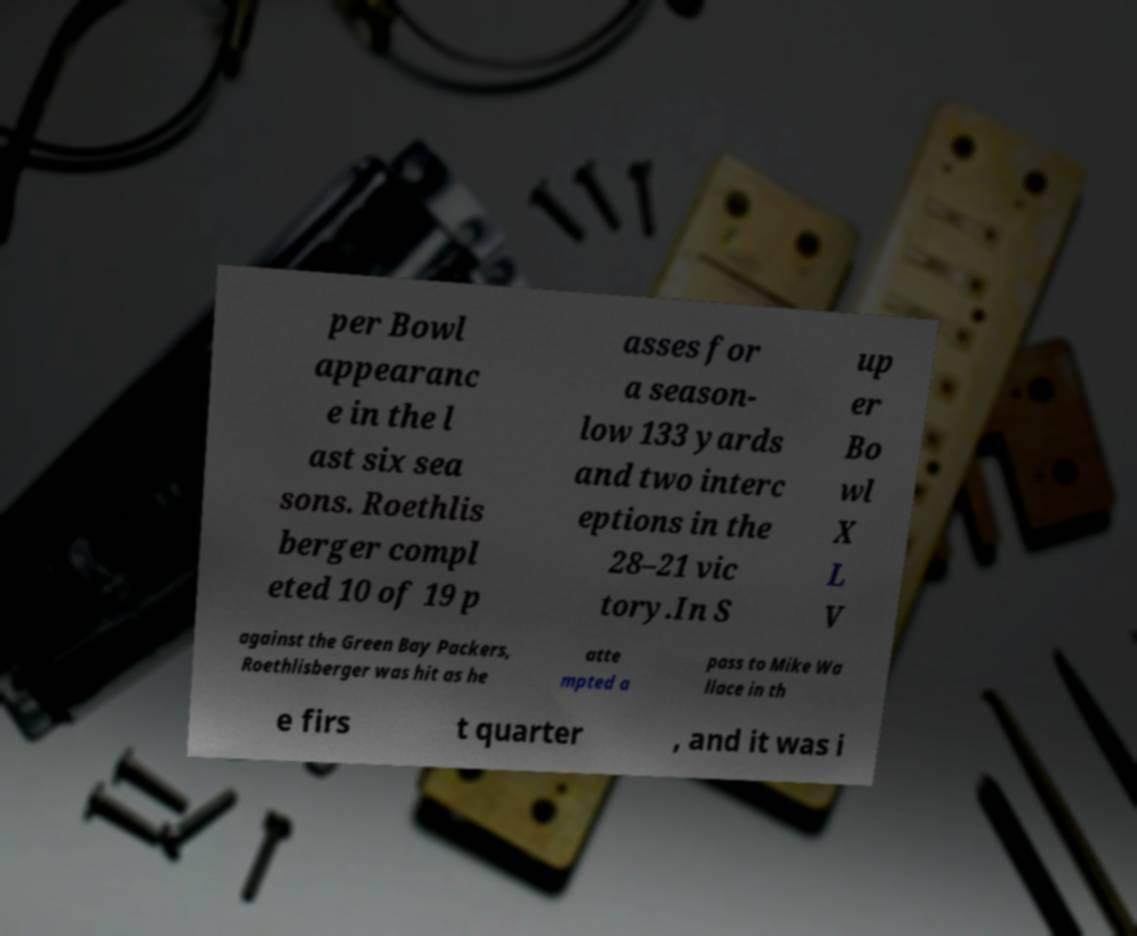I need the written content from this picture converted into text. Can you do that? per Bowl appearanc e in the l ast six sea sons. Roethlis berger compl eted 10 of 19 p asses for a season- low 133 yards and two interc eptions in the 28–21 vic tory.In S up er Bo wl X L V against the Green Bay Packers, Roethlisberger was hit as he atte mpted a pass to Mike Wa llace in th e firs t quarter , and it was i 